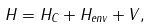<formula> <loc_0><loc_0><loc_500><loc_500>H = H _ { C } + H _ { e n v } + V ,</formula> 